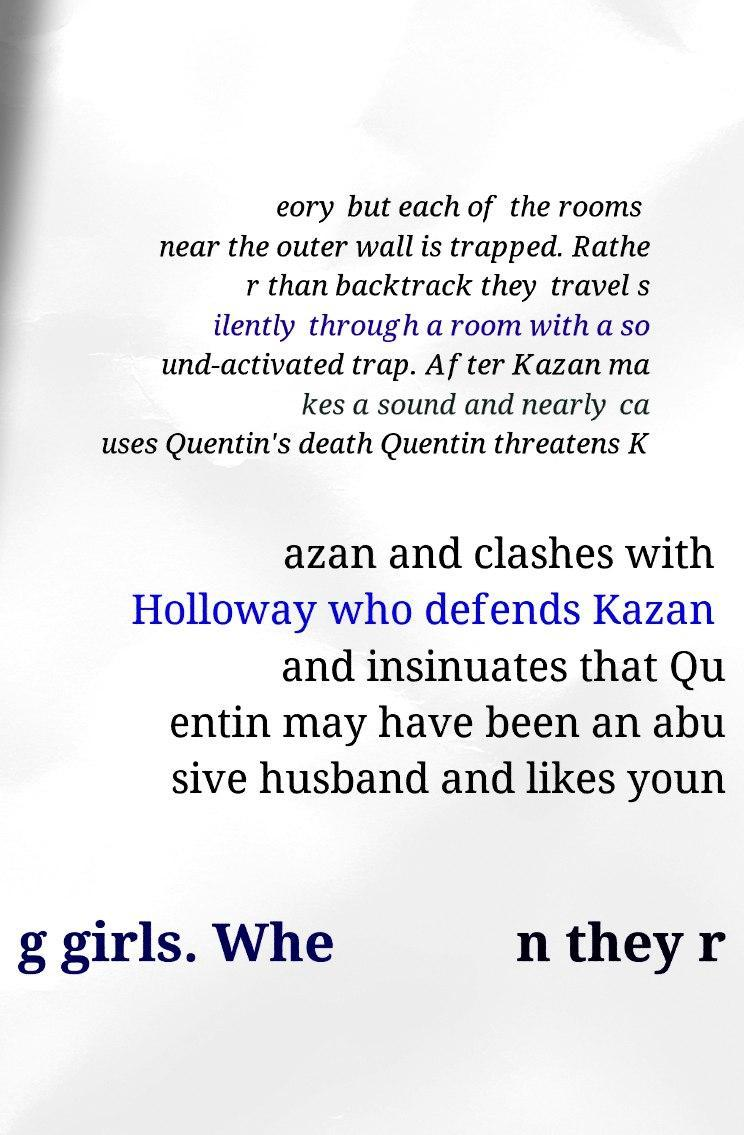Please read and relay the text visible in this image. What does it say? eory but each of the rooms near the outer wall is trapped. Rathe r than backtrack they travel s ilently through a room with a so und-activated trap. After Kazan ma kes a sound and nearly ca uses Quentin's death Quentin threatens K azan and clashes with Holloway who defends Kazan and insinuates that Qu entin may have been an abu sive husband and likes youn g girls. Whe n they r 